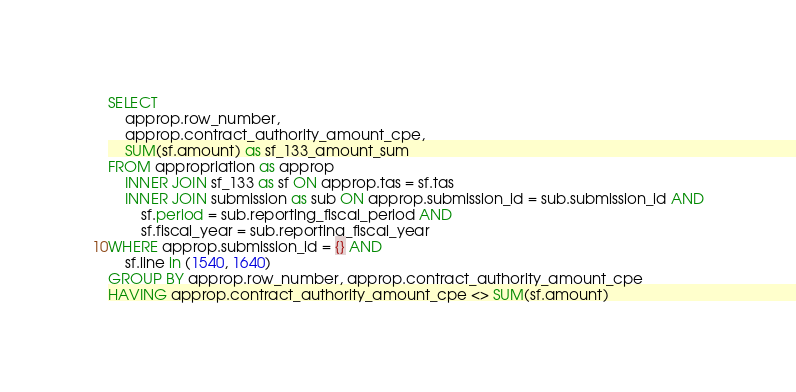<code> <loc_0><loc_0><loc_500><loc_500><_SQL_>SELECT
    approp.row_number,
    approp.contract_authority_amount_cpe,
    SUM(sf.amount) as sf_133_amount_sum
FROM appropriation as approp
    INNER JOIN sf_133 as sf ON approp.tas = sf.tas
    INNER JOIN submission as sub ON approp.submission_id = sub.submission_id AND
        sf.period = sub.reporting_fiscal_period AND
        sf.fiscal_year = sub.reporting_fiscal_year
WHERE approp.submission_id = {} AND
    sf.line in (1540, 1640)
GROUP BY approp.row_number, approp.contract_authority_amount_cpe
HAVING approp.contract_authority_amount_cpe <> SUM(sf.amount)</code> 